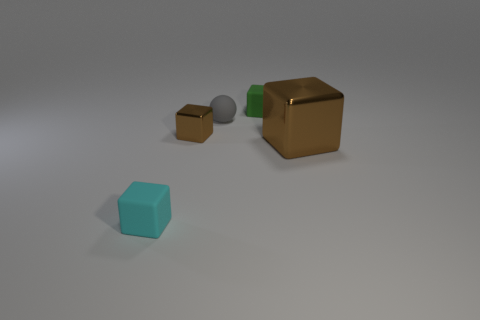How many tiny objects are made of the same material as the gray ball?
Your response must be concise. 2. There is a large metallic thing; is its color the same as the cube on the left side of the tiny brown metal block?
Provide a short and direct response. No. There is a small rubber cube behind the tiny thing in front of the small metal cube; what color is it?
Your answer should be compact. Green. There is a shiny thing that is the same size as the rubber sphere; what color is it?
Give a very brief answer. Brown. Is there another green thing of the same shape as the large thing?
Offer a very short reply. Yes. There is a small gray thing; what shape is it?
Offer a very short reply. Sphere. Is the number of rubber things behind the tiny brown metal thing greater than the number of green cubes to the left of the cyan rubber cube?
Provide a short and direct response. Yes. What number of other objects are the same size as the cyan rubber thing?
Offer a terse response. 3. What material is the tiny object that is behind the small cyan rubber object and in front of the tiny sphere?
Offer a terse response. Metal. What is the material of the cyan object that is the same shape as the tiny green object?
Offer a very short reply. Rubber. 